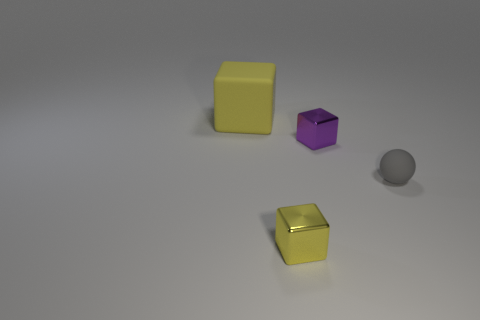There is a small thing that is left of the small purple shiny object; does it have the same shape as the rubber thing that is on the left side of the small yellow block?
Ensure brevity in your answer.  Yes. There is a ball; does it have the same size as the metallic block to the right of the tiny yellow block?
Offer a terse response. Yes. Is the number of purple metal blocks greater than the number of large cyan shiny blocks?
Make the answer very short. Yes. Are the cube in front of the small gray matte object and the yellow thing that is behind the gray ball made of the same material?
Ensure brevity in your answer.  No. What material is the small gray sphere?
Offer a terse response. Rubber. Is the number of tiny matte spheres that are in front of the small gray thing greater than the number of big red cylinders?
Make the answer very short. No. There is a small cube in front of the tiny cube that is behind the small gray rubber thing; how many tiny purple cubes are in front of it?
Your answer should be very brief. 0. What is the object that is both behind the rubber sphere and left of the purple thing made of?
Provide a short and direct response. Rubber. The matte block has what color?
Keep it short and to the point. Yellow. Is the number of small yellow metallic cubes that are on the right side of the tiny gray thing greater than the number of small objects in front of the small purple cube?
Your answer should be very brief. No. 